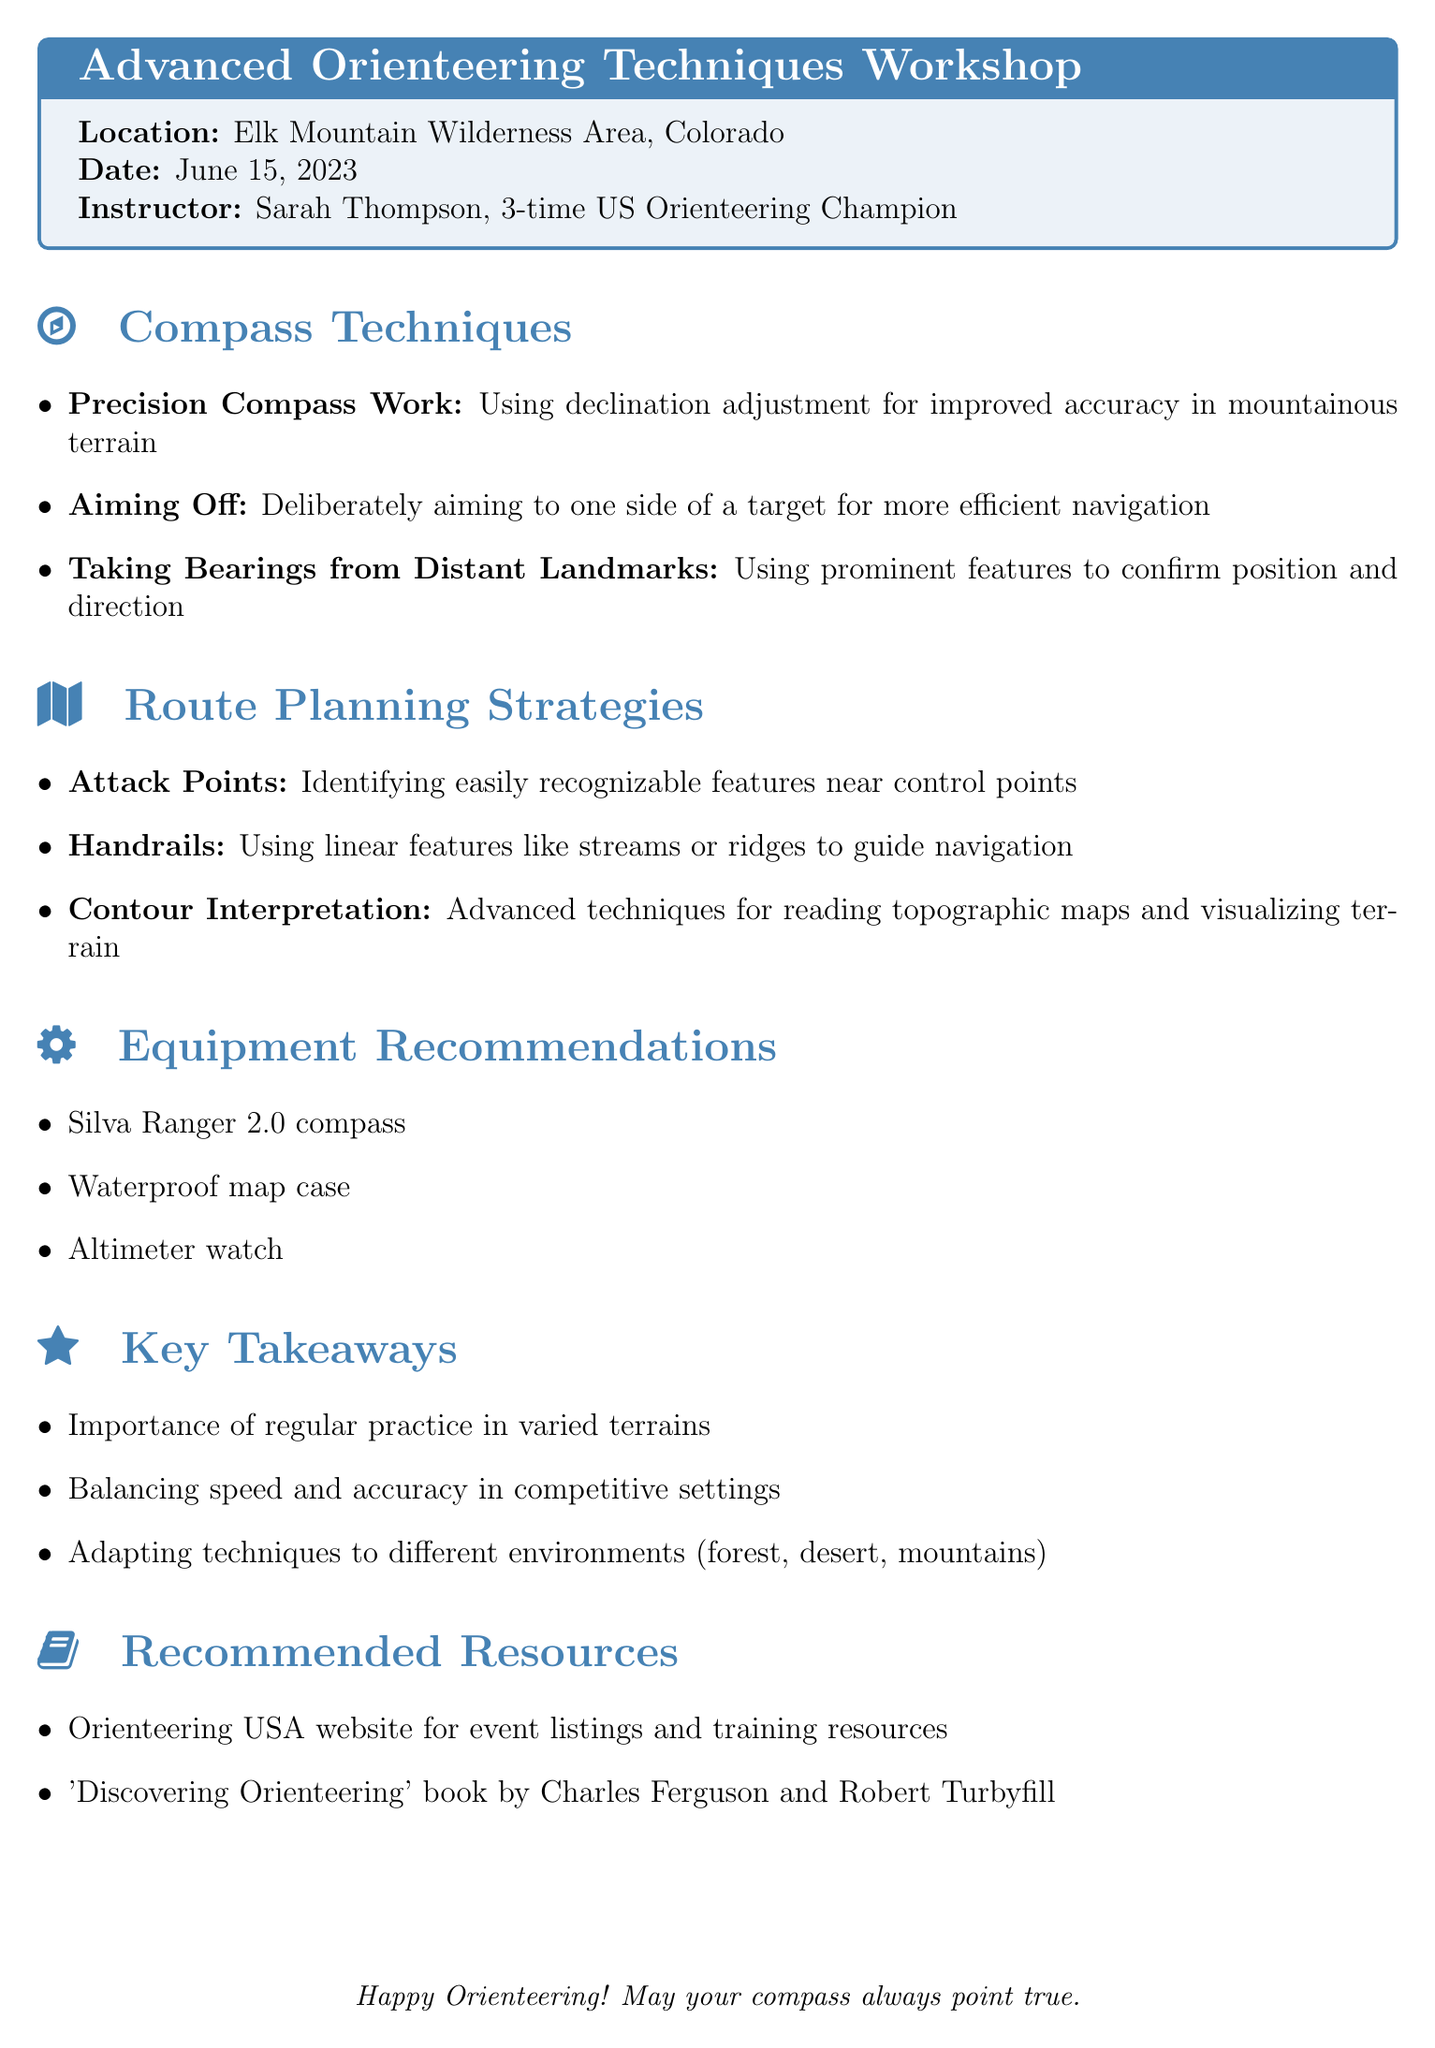What is the title of the workshop? The title of the workshop is clearly stated at the beginning of the document.
Answer: Advanced Orienteering Techniques Workshop Who is the instructor for the workshop? The document specifies the instructor's name and notable achievements.
Answer: Sarah Thompson, 3-time US Orienteering Champion What is one of the recommended equipment items? The equipment recommendations section lists specific equipment for participants.
Answer: Silva Ranger 2.0 compass What technique involves aiming to one side of a target? This is described in the Compass Techniques section.
Answer: Aiming Off What are attack points used for? The document describes their purpose in the Route Planning Strategies section.
Answer: Identifying easily recognizable features near control points How many compass techniques are mentioned? Counting the listed techniques in the document gives this number.
Answer: Three What is a key takeaway from the workshop? The document lists important insights participants should retain from the workshop.
Answer: Importance of regular practice in varied terrains What is one resource recommended for further information? The document includes resources for additional learning.
Answer: Orienteering USA website for event listings and training resources What location hosted the workshop? The exact location of the workshop is provided at the beginning of the document.
Answer: Elk Mountain Wilderness Area, Colorado 